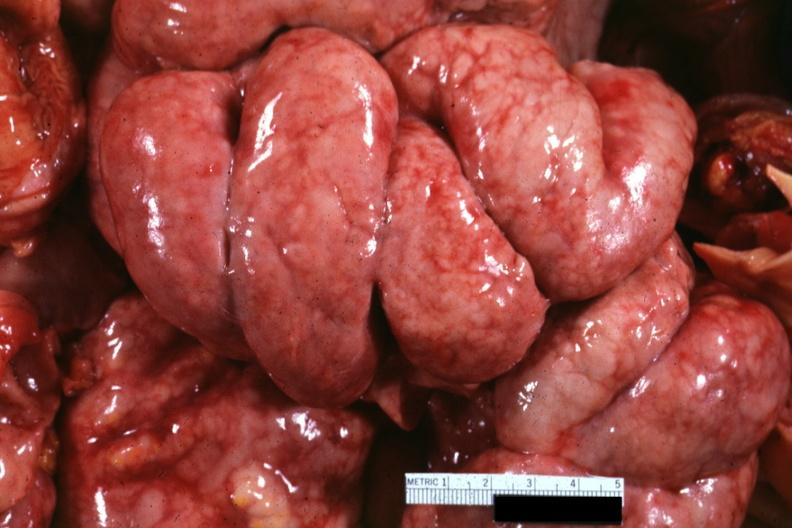how does this image show bowel in situ?
Answer the question using a single word or phrase. With diffuse thickening of peritoneal surfaces due to metastatic carcinoma breast primary i think 